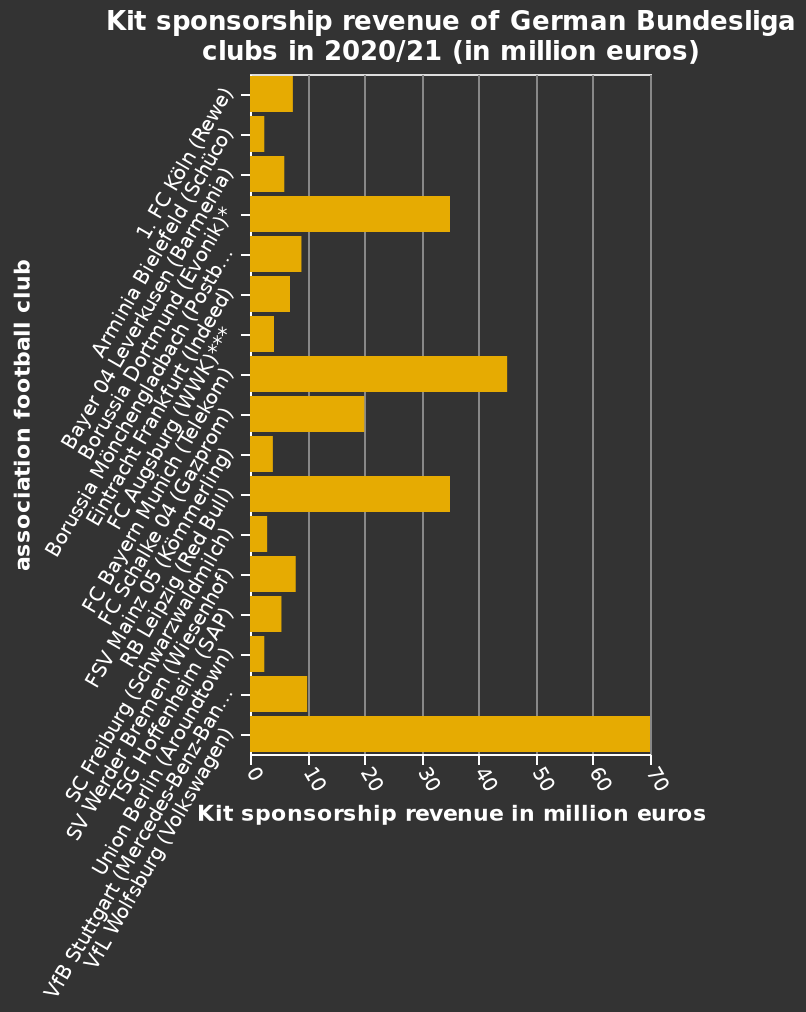<image>
Are there differences in the income streams across the league? Yes, there are wide variations in income streams across the league. What does the y-axis represent on the bar chart?  The y-axis on the bar chart represents the association football clubs participating in the German Bundesliga. Is the revenue stream of the club consistent? Yes, the revenue stream of one club in particular is strong. 